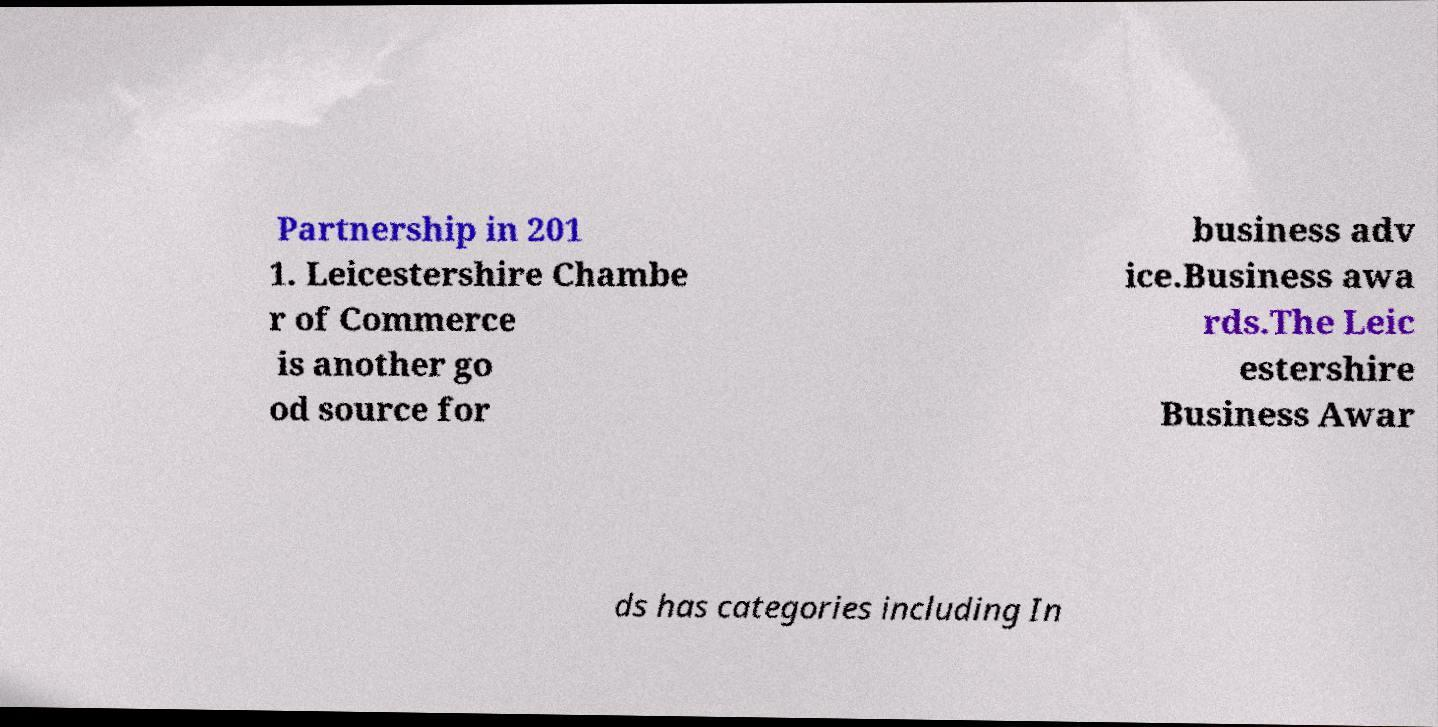For documentation purposes, I need the text within this image transcribed. Could you provide that? Partnership in 201 1. Leicestershire Chambe r of Commerce is another go od source for business adv ice.Business awa rds.The Leic estershire Business Awar ds has categories including In 